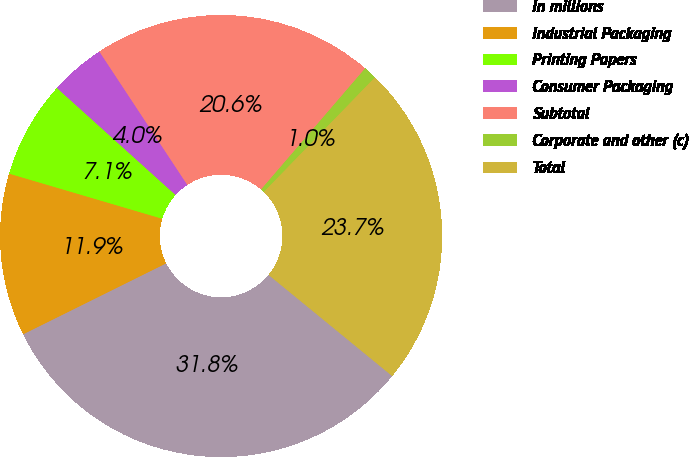<chart> <loc_0><loc_0><loc_500><loc_500><pie_chart><fcel>In millions<fcel>Industrial Packaging<fcel>Printing Papers<fcel>Consumer Packaging<fcel>Subtotal<fcel>Corporate and other (c)<fcel>Total<nl><fcel>31.76%<fcel>11.89%<fcel>7.12%<fcel>4.04%<fcel>20.58%<fcel>0.96%<fcel>23.66%<nl></chart> 